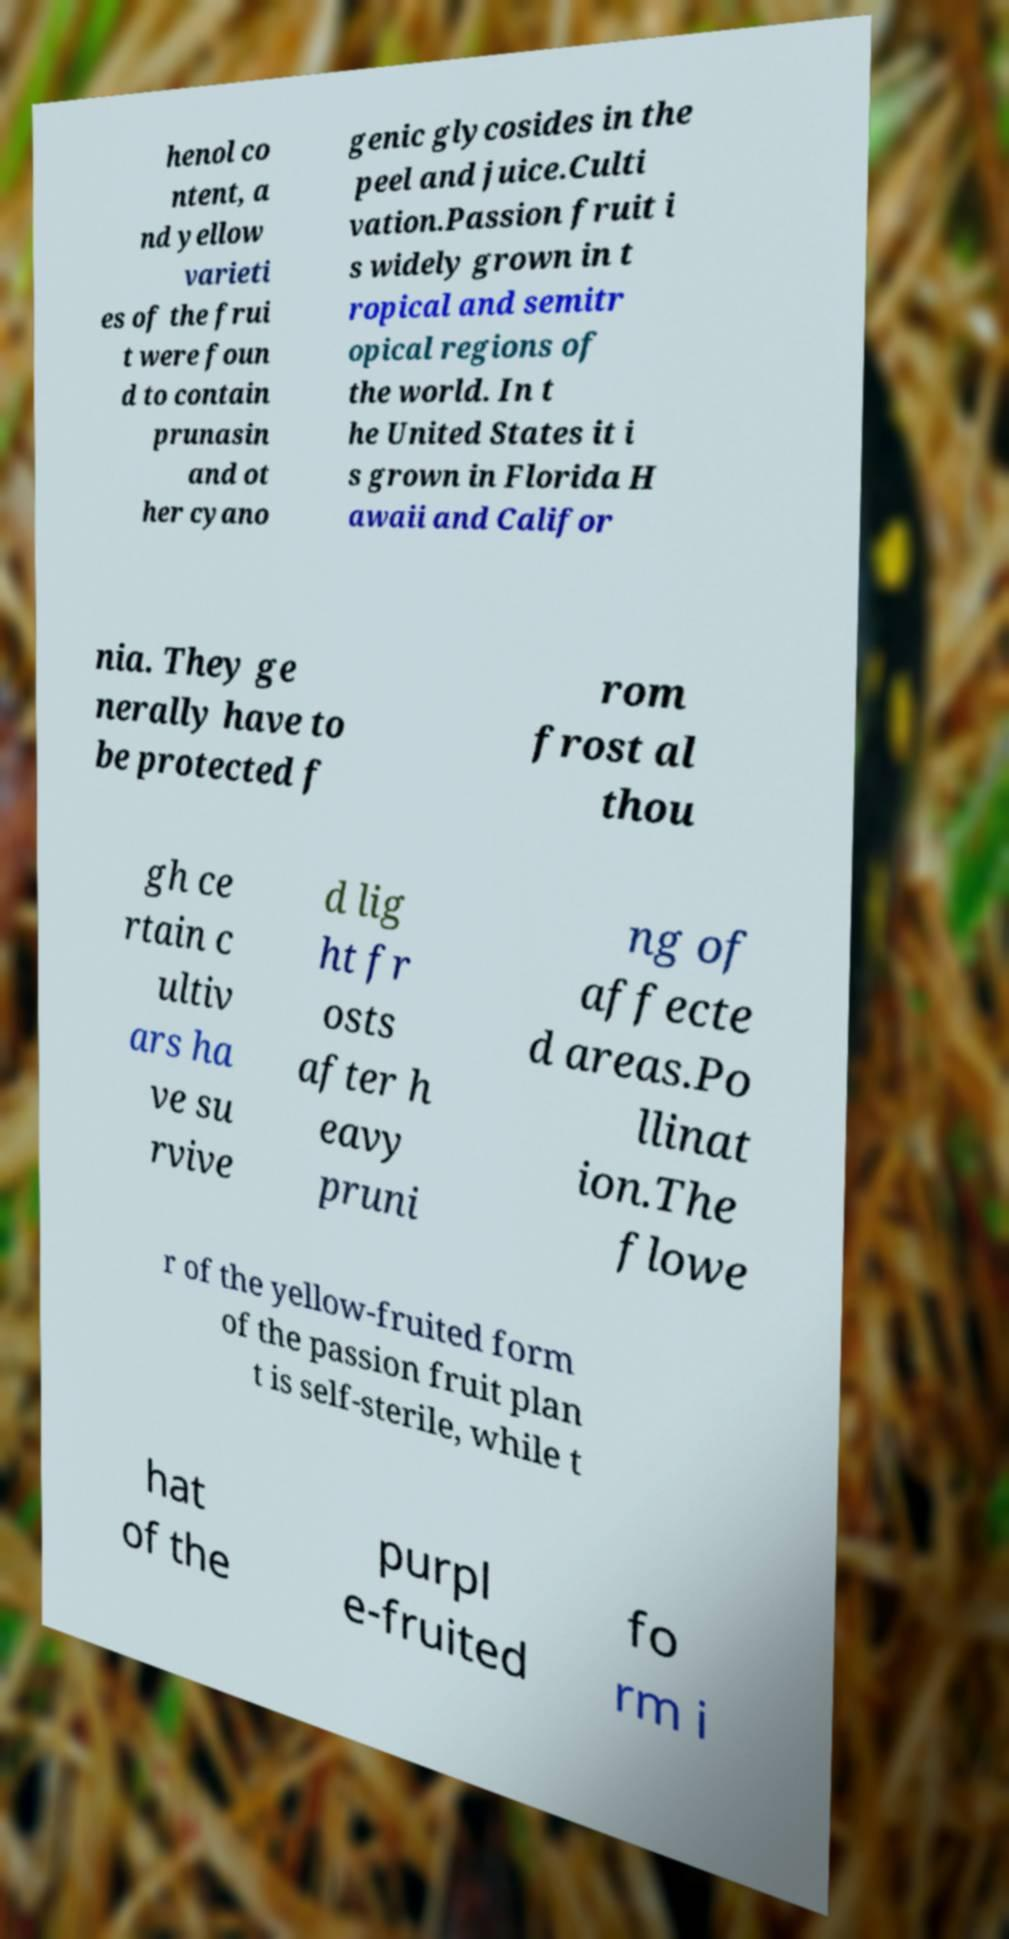Could you extract and type out the text from this image? henol co ntent, a nd yellow varieti es of the frui t were foun d to contain prunasin and ot her cyano genic glycosides in the peel and juice.Culti vation.Passion fruit i s widely grown in t ropical and semitr opical regions of the world. In t he United States it i s grown in Florida H awaii and Califor nia. They ge nerally have to be protected f rom frost al thou gh ce rtain c ultiv ars ha ve su rvive d lig ht fr osts after h eavy pruni ng of affecte d areas.Po llinat ion.The flowe r of the yellow-fruited form of the passion fruit plan t is self-sterile, while t hat of the purpl e-fruited fo rm i 